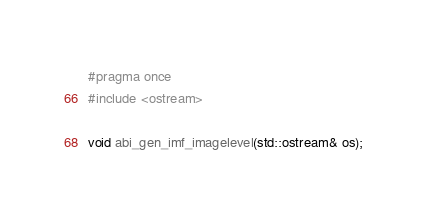<code> <loc_0><loc_0><loc_500><loc_500><_C++_>#pragma once
#include <ostream>

void abi_gen_imf_imagelevel(std::ostream& os);
</code> 